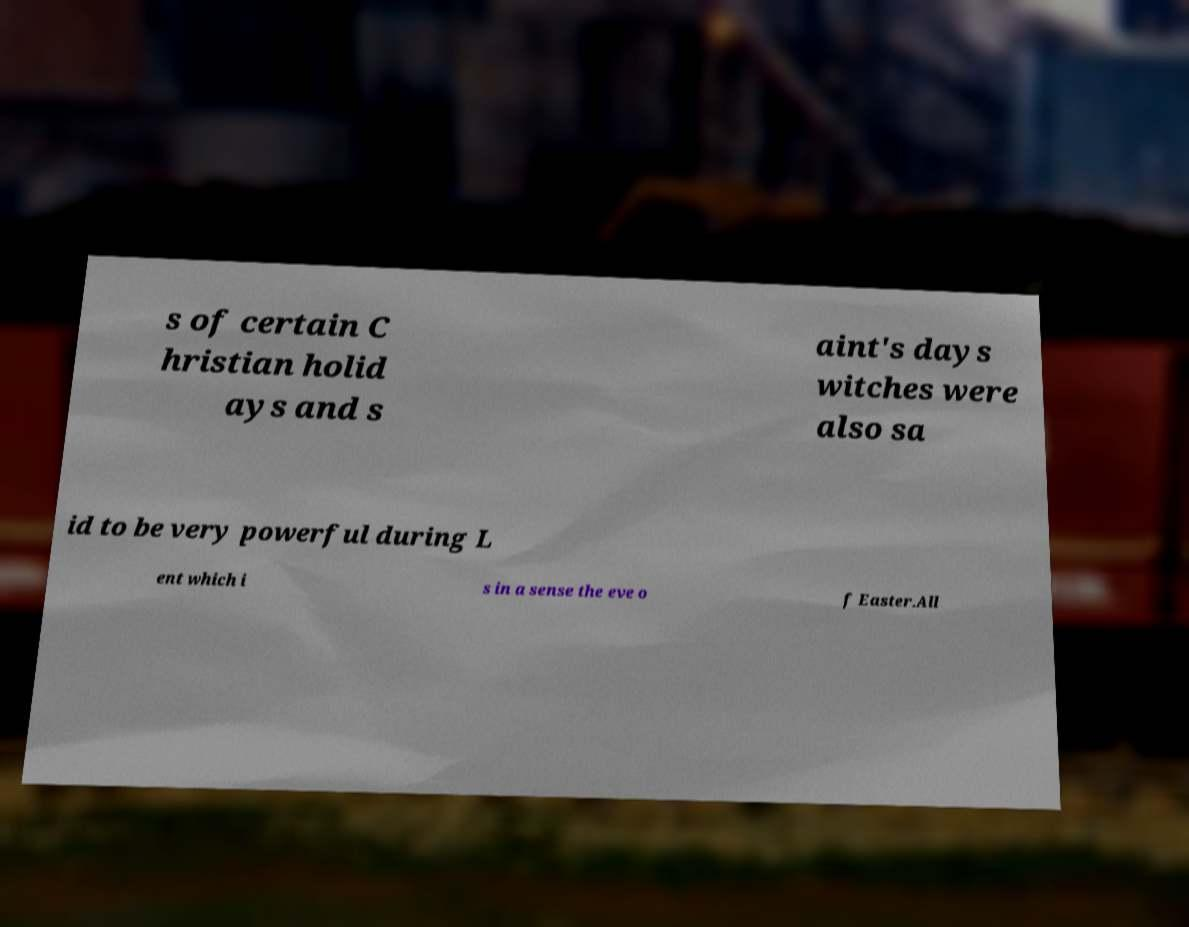I need the written content from this picture converted into text. Can you do that? s of certain C hristian holid ays and s aint's days witches were also sa id to be very powerful during L ent which i s in a sense the eve o f Easter.All 